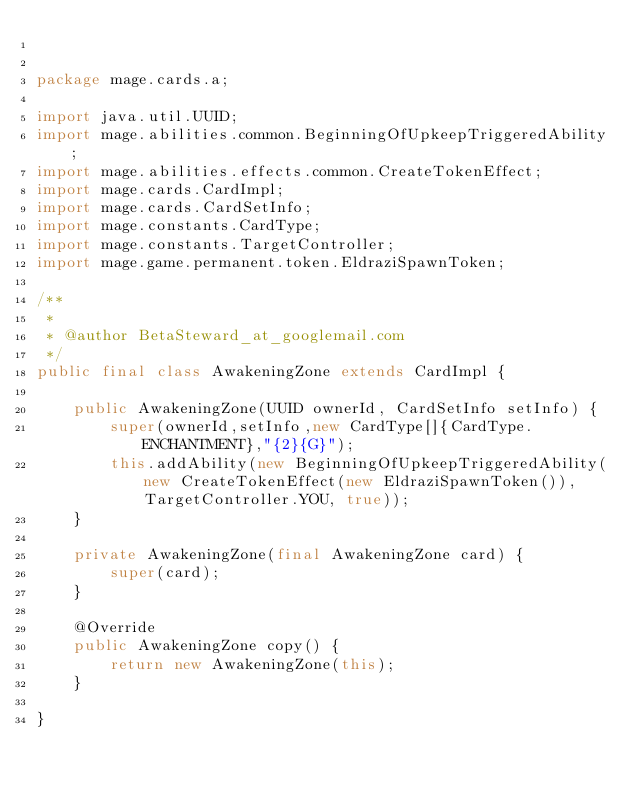Convert code to text. <code><loc_0><loc_0><loc_500><loc_500><_Java_>

package mage.cards.a;

import java.util.UUID;
import mage.abilities.common.BeginningOfUpkeepTriggeredAbility;
import mage.abilities.effects.common.CreateTokenEffect;
import mage.cards.CardImpl;
import mage.cards.CardSetInfo;
import mage.constants.CardType;
import mage.constants.TargetController;
import mage.game.permanent.token.EldraziSpawnToken;

/**
 *
 * @author BetaSteward_at_googlemail.com
 */
public final class AwakeningZone extends CardImpl {

    public AwakeningZone(UUID ownerId, CardSetInfo setInfo) {
        super(ownerId,setInfo,new CardType[]{CardType.ENCHANTMENT},"{2}{G}");
        this.addAbility(new BeginningOfUpkeepTriggeredAbility(new CreateTokenEffect(new EldraziSpawnToken()), TargetController.YOU, true));
    }

    private AwakeningZone(final AwakeningZone card) {
        super(card);
    }

    @Override
    public AwakeningZone copy() {
        return new AwakeningZone(this);
    }

}
</code> 